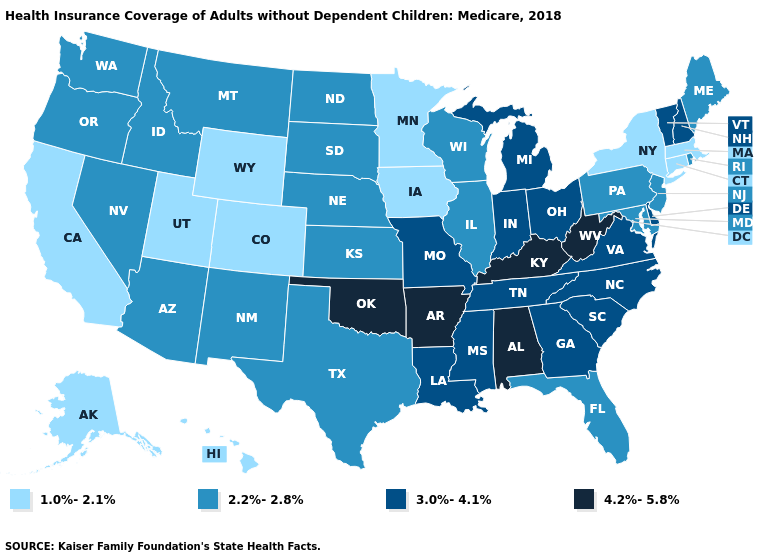Which states have the lowest value in the Northeast?
Short answer required. Connecticut, Massachusetts, New York. Name the states that have a value in the range 2.2%-2.8%?
Quick response, please. Arizona, Florida, Idaho, Illinois, Kansas, Maine, Maryland, Montana, Nebraska, Nevada, New Jersey, New Mexico, North Dakota, Oregon, Pennsylvania, Rhode Island, South Dakota, Texas, Washington, Wisconsin. Does Minnesota have the same value as Colorado?
Quick response, please. Yes. Among the states that border Mississippi , which have the lowest value?
Write a very short answer. Louisiana, Tennessee. What is the highest value in the USA?
Keep it brief. 4.2%-5.8%. What is the lowest value in the USA?
Concise answer only. 1.0%-2.1%. What is the lowest value in the USA?
Write a very short answer. 1.0%-2.1%. What is the value of California?
Keep it brief. 1.0%-2.1%. Name the states that have a value in the range 3.0%-4.1%?
Concise answer only. Delaware, Georgia, Indiana, Louisiana, Michigan, Mississippi, Missouri, New Hampshire, North Carolina, Ohio, South Carolina, Tennessee, Vermont, Virginia. Does the first symbol in the legend represent the smallest category?
Write a very short answer. Yes. Name the states that have a value in the range 2.2%-2.8%?
Be succinct. Arizona, Florida, Idaho, Illinois, Kansas, Maine, Maryland, Montana, Nebraska, Nevada, New Jersey, New Mexico, North Dakota, Oregon, Pennsylvania, Rhode Island, South Dakota, Texas, Washington, Wisconsin. What is the value of Nebraska?
Be succinct. 2.2%-2.8%. Name the states that have a value in the range 1.0%-2.1%?
Short answer required. Alaska, California, Colorado, Connecticut, Hawaii, Iowa, Massachusetts, Minnesota, New York, Utah, Wyoming. What is the highest value in the Northeast ?
Concise answer only. 3.0%-4.1%. 